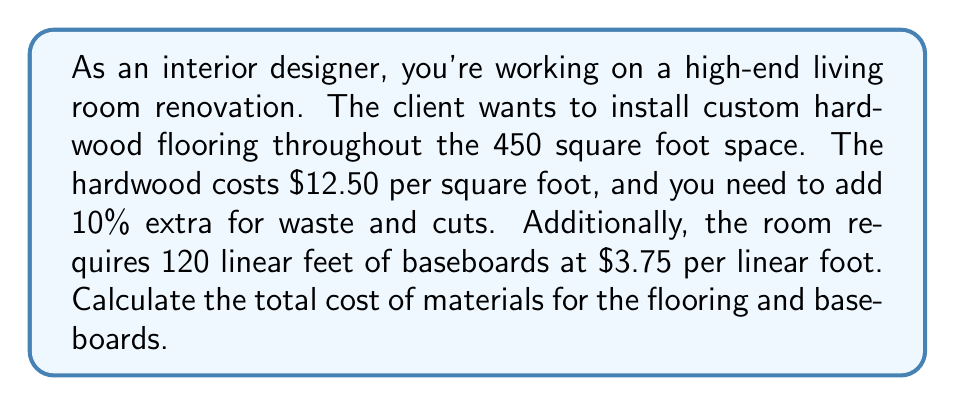What is the answer to this math problem? Let's break this problem down into steps:

1. Calculate the cost of the hardwood flooring:
   a. Area of the room: 450 sq ft
   b. Add 10% for waste: $450 \times 1.1 = 495$ sq ft
   c. Cost per square foot: $12.50
   d. Total cost of hardwood: $495 \times \$12.50 = \$6,187.50$

2. Calculate the cost of the baseboards:
   a. Linear feet of baseboards: 120 ft
   b. Cost per linear foot: $3.75
   c. Total cost of baseboards: $120 \times \$3.75 = \$450$

3. Sum up the total cost:
   Total cost = Cost of hardwood + Cost of baseboards
   $$ \text{Total cost} = \$6,187.50 + \$450 = \$6,637.50 $$
Answer: $6,637.50 